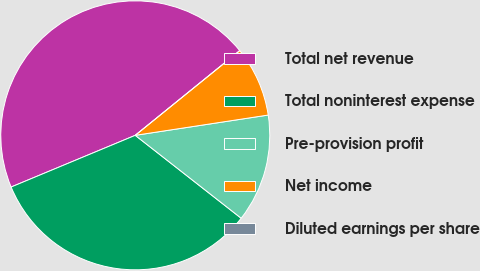<chart> <loc_0><loc_0><loc_500><loc_500><pie_chart><fcel>Total net revenue<fcel>Total noninterest expense<fcel>Pre-provision profit<fcel>Net income<fcel>Diluted earnings per share<nl><fcel>45.44%<fcel>33.15%<fcel>12.98%<fcel>8.43%<fcel>0.0%<nl></chart> 